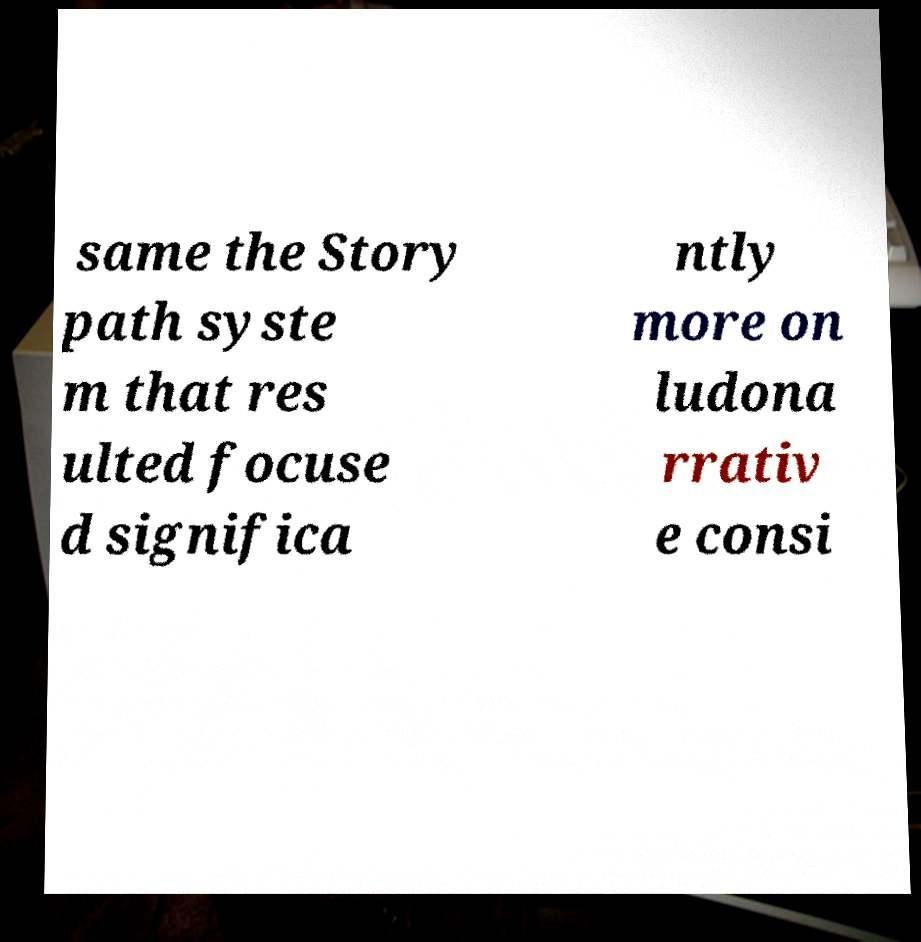For documentation purposes, I need the text within this image transcribed. Could you provide that? same the Story path syste m that res ulted focuse d significa ntly more on ludona rrativ e consi 